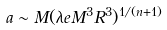<formula> <loc_0><loc_0><loc_500><loc_500>a \sim M ( \lambda e M ^ { 3 } R ^ { 3 } ) ^ { 1 / ( n + 1 ) }</formula> 